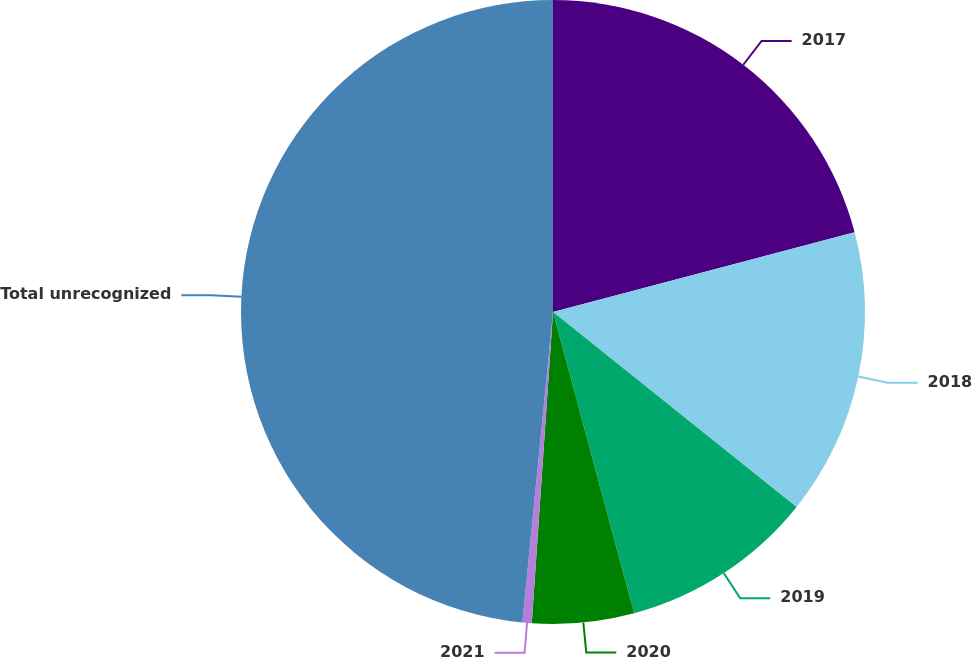Convert chart to OTSL. <chart><loc_0><loc_0><loc_500><loc_500><pie_chart><fcel>2017<fcel>2018<fcel>2019<fcel>2020<fcel>2021<fcel>Total unrecognized<nl><fcel>20.88%<fcel>14.86%<fcel>10.07%<fcel>5.27%<fcel>0.48%<fcel>48.43%<nl></chart> 